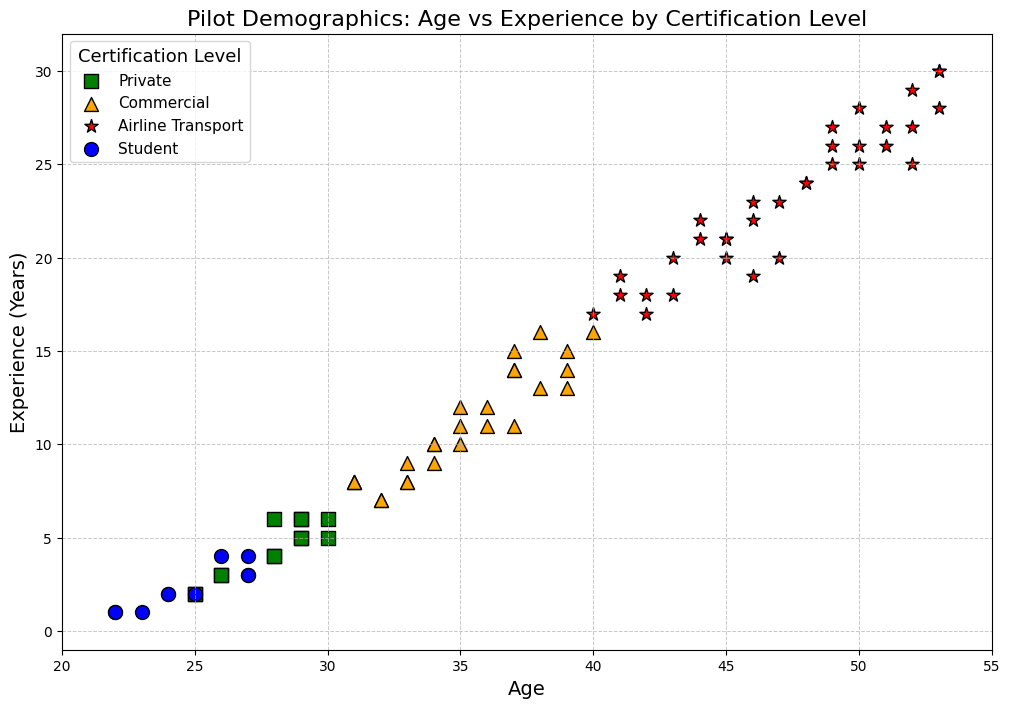Which certification level shows the widest range of age distribution? To determine the widest range of age distribution, observe each certification group's highest and lowest ages. For example, the Airline Transport group ranges roughly from ages 41 to 53, the widest range visually.
Answer: Airline Transport Which group has the least amount of experience? Visually identify the group represented by points near the lower end of the experience axis. The Student group has the lowest experience levels.
Answer: Student What is the average experience (years) of pilots aged 50 years and above? Look at the plot points associated with ages 50, 51, 52, and 53, then calculate the average of their experience values: (25 + 26 + 27 + 28 + 29 + 30) / 6.
Answer: 27.5 years Are there any Student pilots aged over 30? Check the plot for any blue circles above the age of 30. There are no blue circles above age 30.
Answer: No Between Private and Commercial pilots, which group generally has higher experience levels? Compare the green squares (Private) with the orange triangles (Commercial). Orange triangles tend to be higher on the experience axis.
Answer: Commercial How does the experience of Airline Transport pilots compare to Private pilots in terms of average years? Airline Transport pilots are represented by red stars and Private pilots by green squares. Estimate the experience values and average them for both groups, then compare. Airline Transport pilots, on average, have more experience years.
Answer: Airline Transport What trends can you observe about age and experience among Commercial pilots? Orange triangles represent Commercial pilots. They show an upward trend where pilots' experience generally increases with age.
Answer: Positive correlation between age and experience How many certification levels are represented in the plot? Count the distinct colors and markers representing different certification levels: Student (blue circles), Private (green squares), Commercial (orange triangles), and Airline Transport (red stars).
Answer: 4 Does the plot show any overlap between Student and Private pilots in terms of age? Check for any blue circles (Student) and green squares (Private) that share similar age values. There are ages like 25, 26, 27, and 28 where both appear.
Answer: Yes Is there a certification level that visually stands out in terms of experience and age distribution? Observe the spread and clustering of the different marker types. The Airline Transport group's red stars tend to be widely distributed and at higher experience levels.
Answer: Airline Transport 